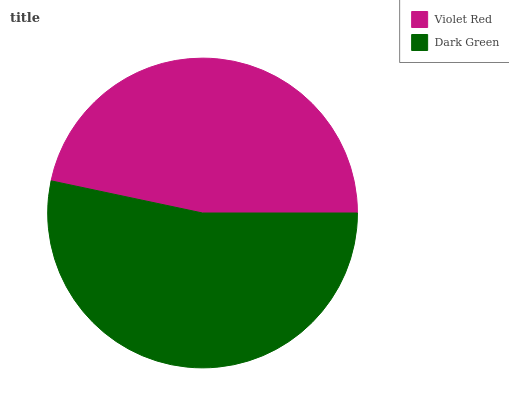Is Violet Red the minimum?
Answer yes or no. Yes. Is Dark Green the maximum?
Answer yes or no. Yes. Is Dark Green the minimum?
Answer yes or no. No. Is Dark Green greater than Violet Red?
Answer yes or no. Yes. Is Violet Red less than Dark Green?
Answer yes or no. Yes. Is Violet Red greater than Dark Green?
Answer yes or no. No. Is Dark Green less than Violet Red?
Answer yes or no. No. Is Dark Green the high median?
Answer yes or no. Yes. Is Violet Red the low median?
Answer yes or no. Yes. Is Violet Red the high median?
Answer yes or no. No. Is Dark Green the low median?
Answer yes or no. No. 